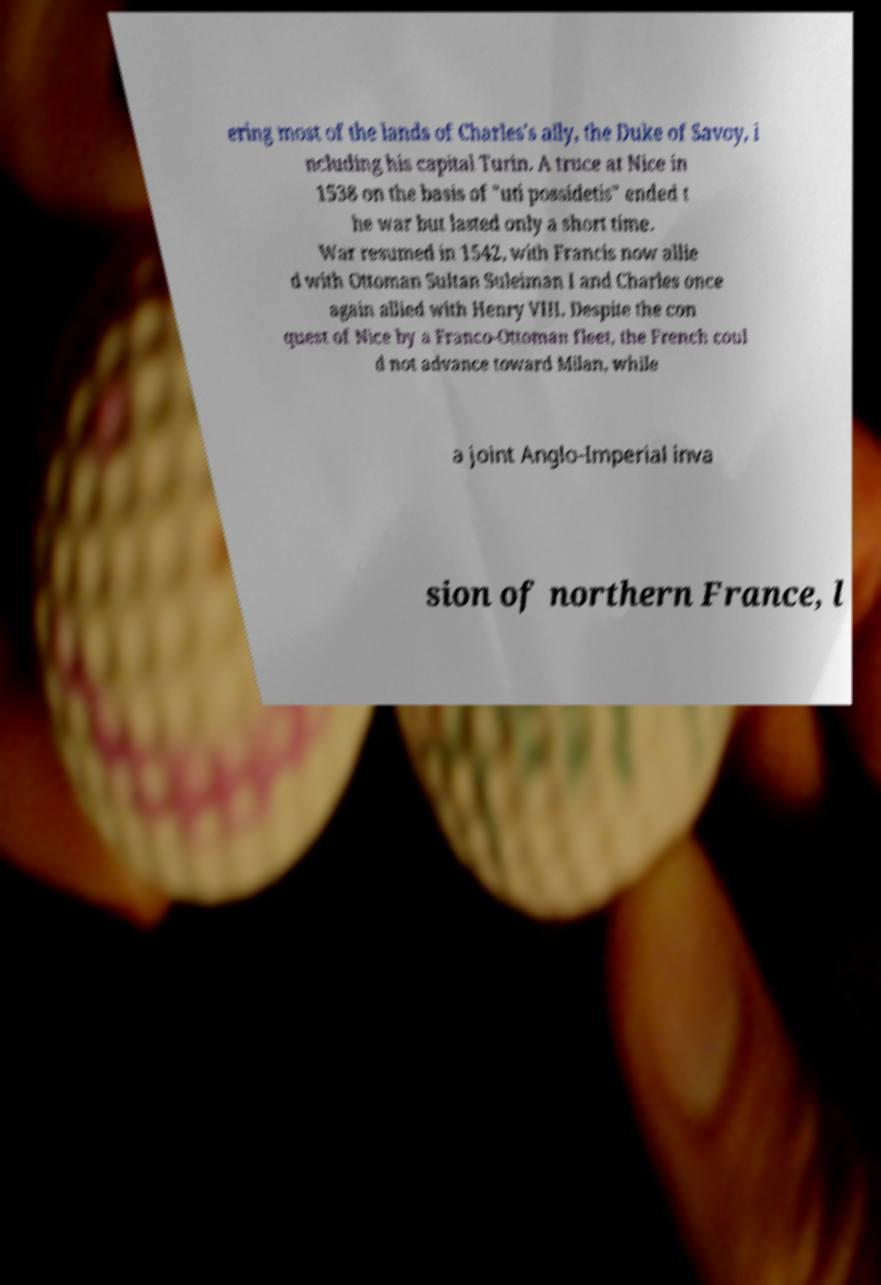I need the written content from this picture converted into text. Can you do that? ering most of the lands of Charles's ally, the Duke of Savoy, i ncluding his capital Turin. A truce at Nice in 1538 on the basis of "uti possidetis" ended t he war but lasted only a short time. War resumed in 1542, with Francis now allie d with Ottoman Sultan Suleiman I and Charles once again allied with Henry VIII. Despite the con quest of Nice by a Franco-Ottoman fleet, the French coul d not advance toward Milan, while a joint Anglo-Imperial inva sion of northern France, l 